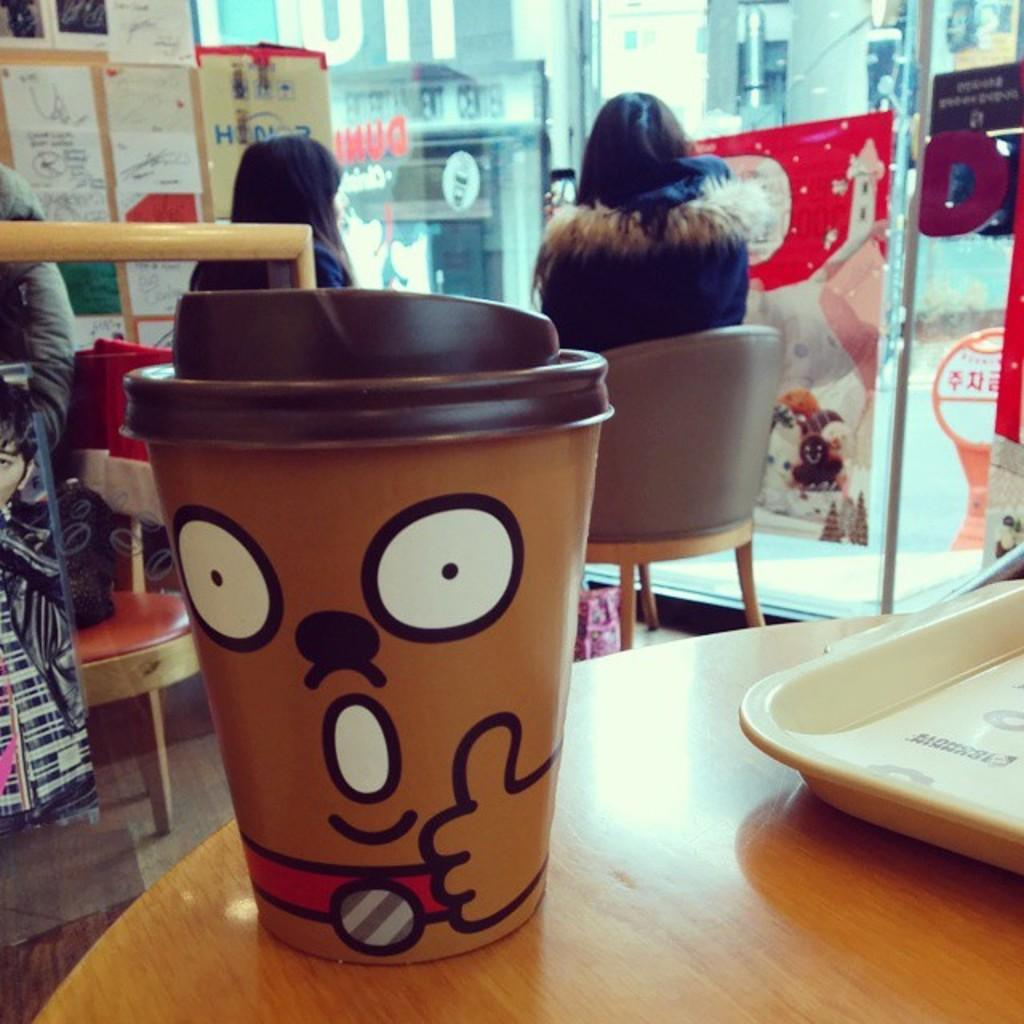What is the main piece of furniture in the image? There is a table in the image. Who is present at the table? Two people are sitting at the table. What is on the table besides the people? There is a tray and a glass on the table. What can be seen on the left side of the image? There are posters on the left side of the image. Absurd Question/Answer: What type of song is being played in the background of the image? There is no indication of any music or song in the image. Is there any popcorn or chicken visible in the image? No, there is no popcorn or chicken present in the image. 